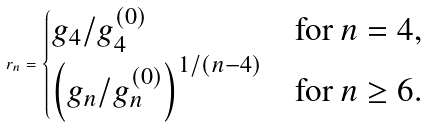Convert formula to latex. <formula><loc_0><loc_0><loc_500><loc_500>r _ { n } = \begin{cases} g _ { 4 } / g _ { 4 } ^ { ( 0 ) } & \text {for $n=4$,} \\ \left ( g _ { n } / g _ { n } ^ { ( 0 ) } \right ) ^ { 1 / ( n - 4 ) } & \text {for $n\geq6$.} \end{cases}</formula> 